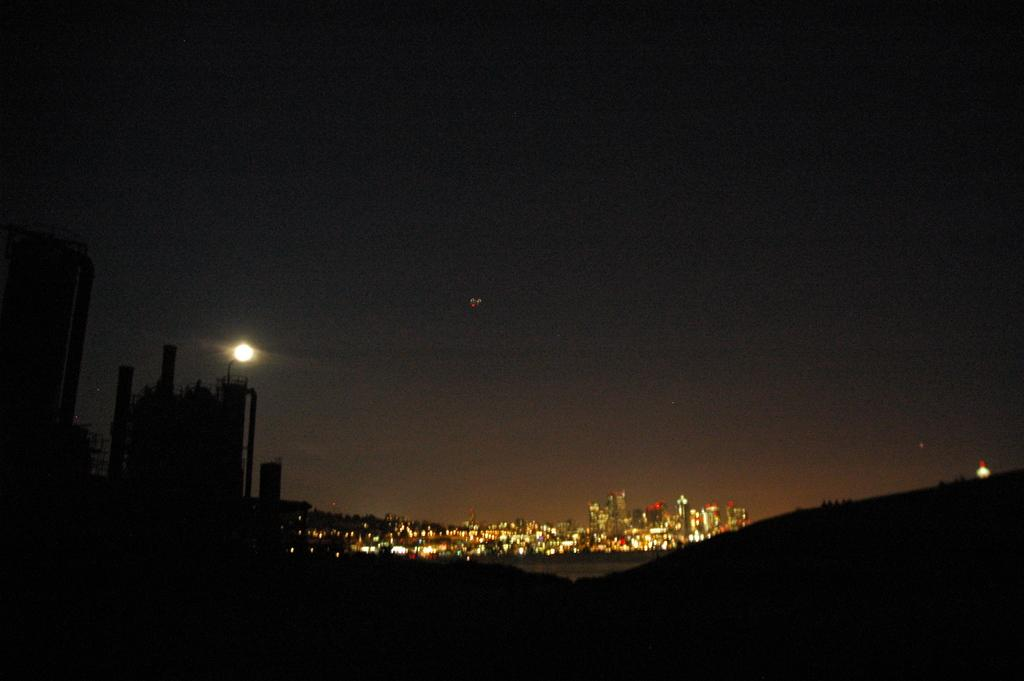What celestial object can be seen in the image? The moon is visible in the image. What type of structures are present in the image? There are buildings with lights in the image. What else can be seen in the sky besides the moon? The sky is visible in the image, but no other celestial objects or phenomena are mentioned in the provided facts. What type of list is being checked off by the horse in the image? There is no horse present in the image, so it is not possible to answer that question. 